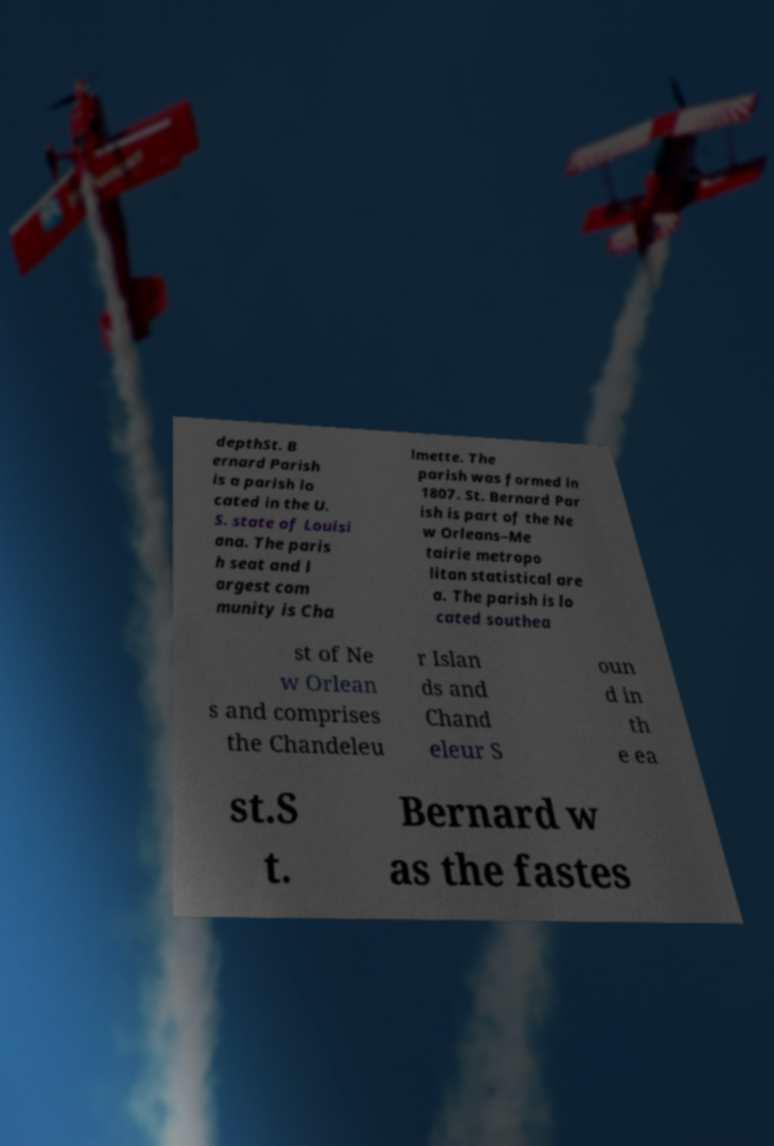Could you assist in decoding the text presented in this image and type it out clearly? depthSt. B ernard Parish is a parish lo cated in the U. S. state of Louisi ana. The paris h seat and l argest com munity is Cha lmette. The parish was formed in 1807. St. Bernard Par ish is part of the Ne w Orleans–Me tairie metropo litan statistical are a. The parish is lo cated southea st of Ne w Orlean s and comprises the Chandeleu r Islan ds and Chand eleur S oun d in th e ea st.S t. Bernard w as the fastes 